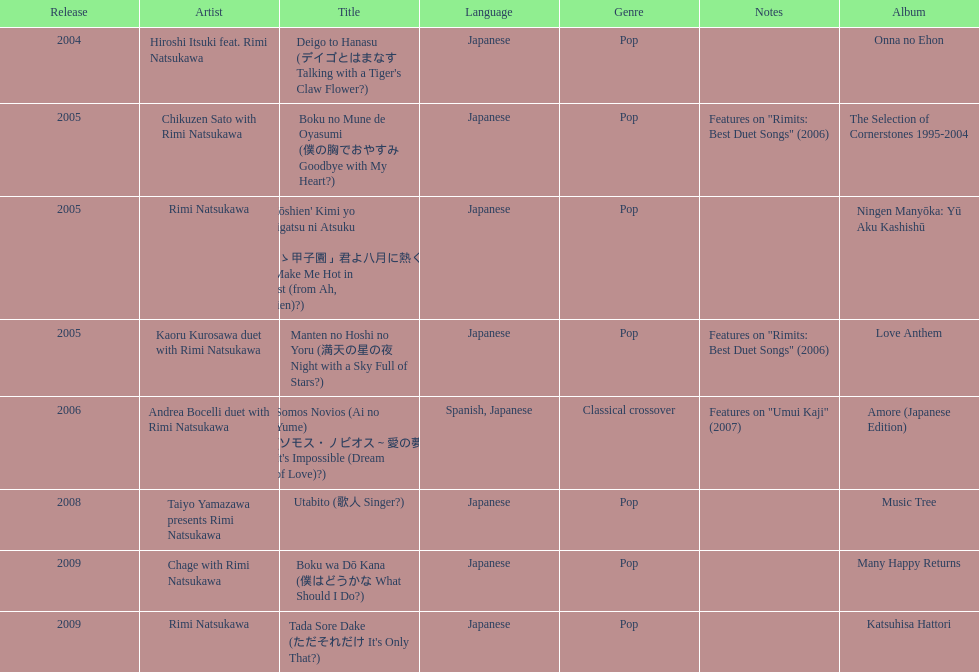What song was this artist on after utabito? Boku wa Dō Kana. 